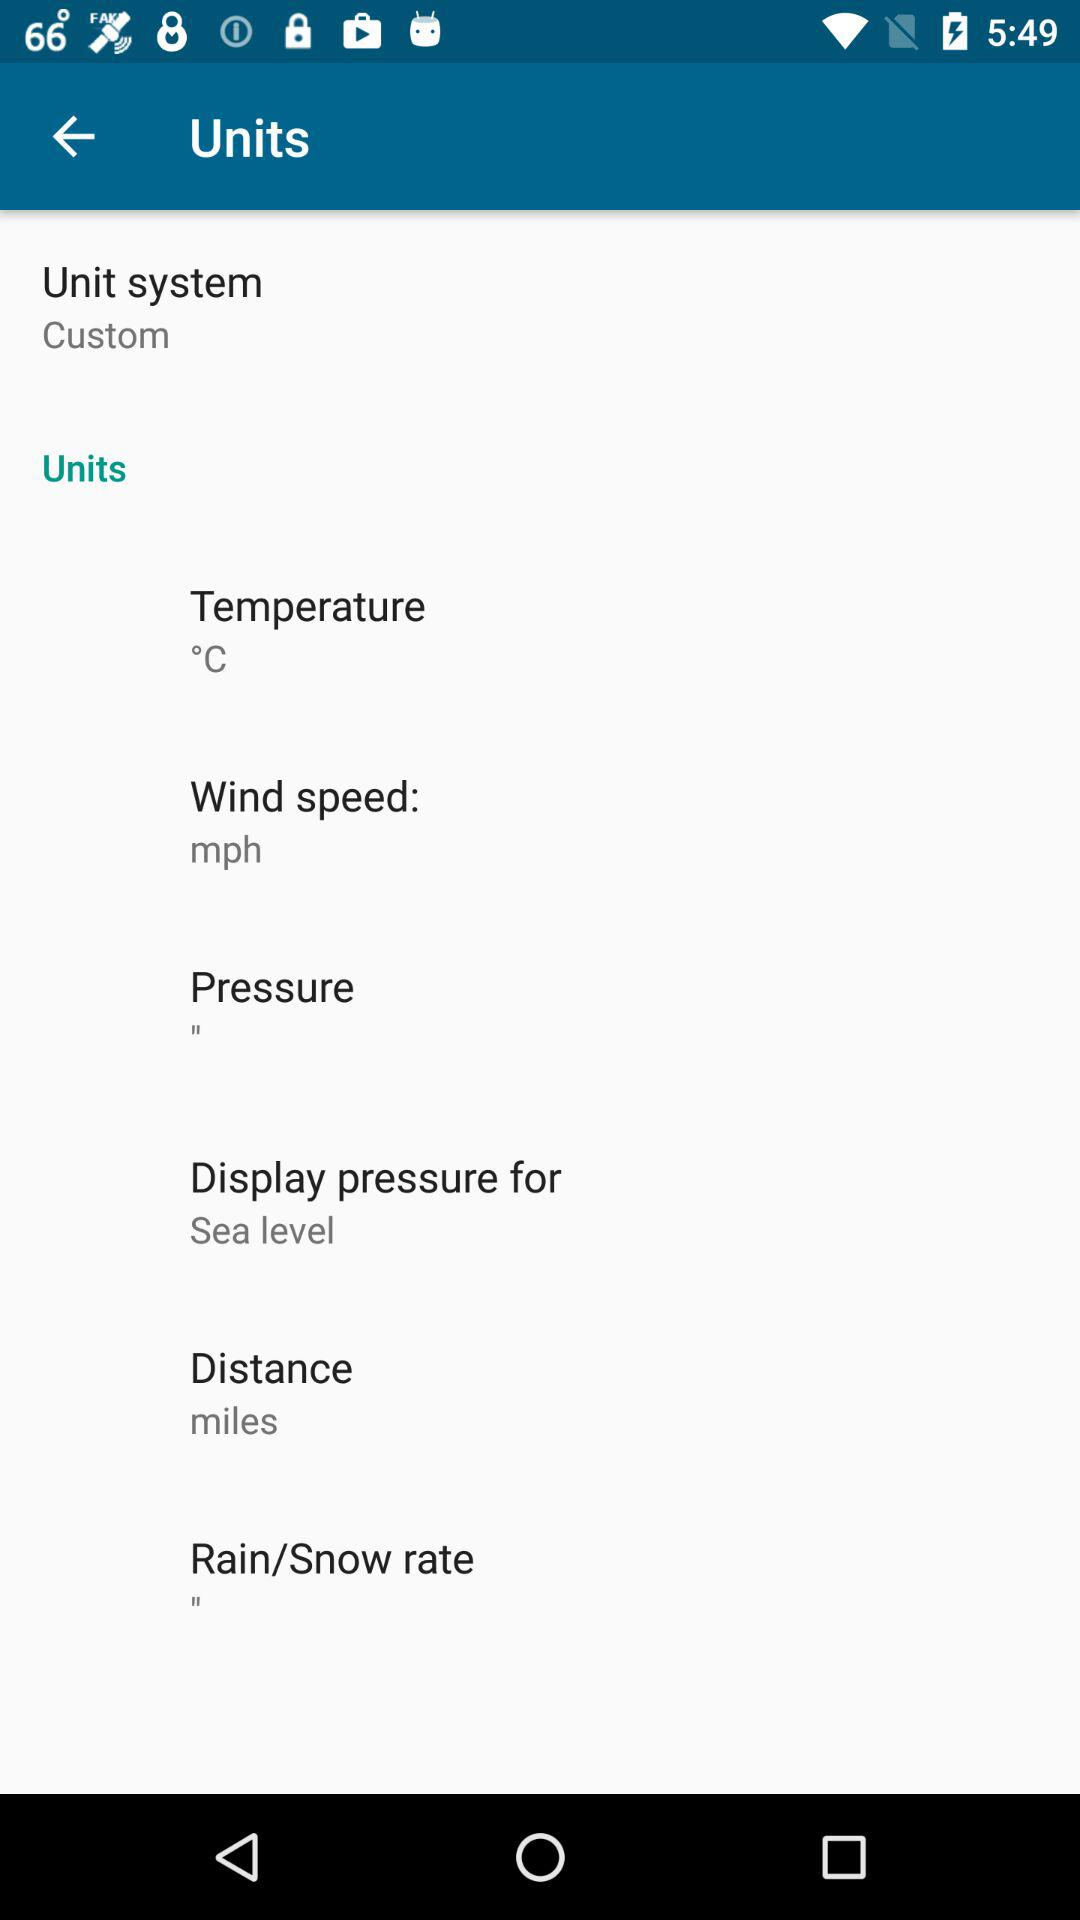In what unit can we measure distance? You can measure distance in miles. 